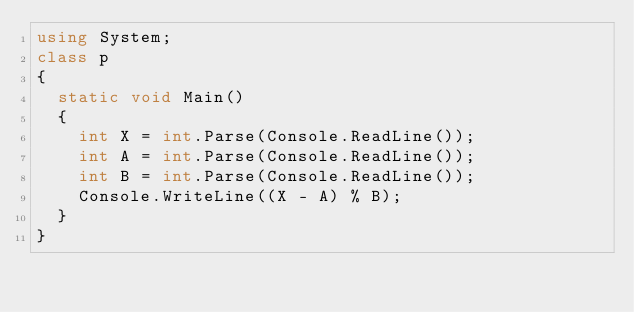<code> <loc_0><loc_0><loc_500><loc_500><_C#_>using System;
class p
{
  static void Main()
  {
    int X = int.Parse(Console.ReadLine());
    int A = int.Parse(Console.ReadLine());
    int B = int.Parse(Console.ReadLine());
    Console.WriteLine((X - A) % B);
  }
}
</code> 